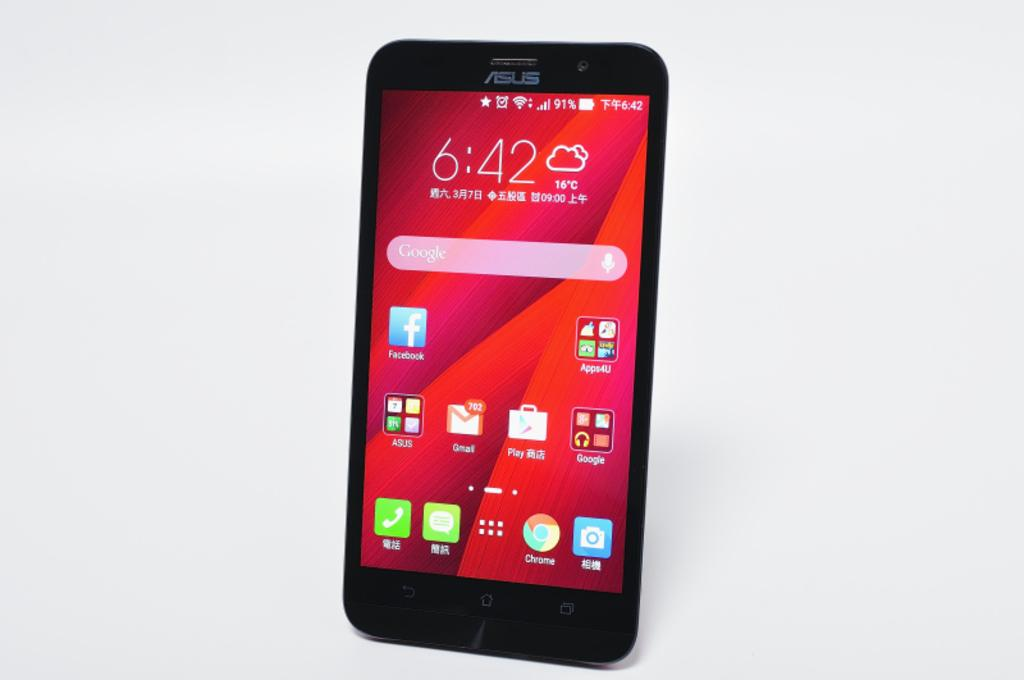What type of device is shown in the image? The image is of a mobile device. What can be seen on the screen of the device? There are numbers, icons, folders, and words on the screen. Can you describe the numbers on the screen? The numbers on the screen are part of the content displayed on the mobile device. What do the icons on the screen represent? The icons on the screen represent various functions or applications on the mobile device. How does the jellyfish contribute to the growth of the plants in the image? There is no jellyfish present in the image, and therefore no such interaction can be observed. 